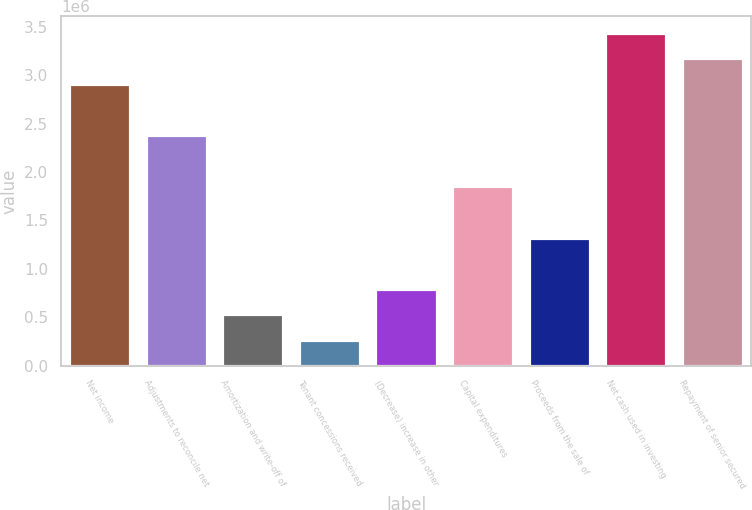Convert chart to OTSL. <chart><loc_0><loc_0><loc_500><loc_500><bar_chart><fcel>Net income<fcel>Adjustments to reconcile net<fcel>Amortization and write-off of<fcel>Tenant concessions received<fcel>(Decrease) increase in other<fcel>Capital expenditures<fcel>Proceeds from the sale of<fcel>Net cash used in investing<fcel>Repayment of senior secured<nl><fcel>2.90769e+06<fcel>2.37931e+06<fcel>529961<fcel>265768<fcel>794153<fcel>1.85092e+06<fcel>1.32254e+06<fcel>3.43608e+06<fcel>3.17188e+06<nl></chart> 